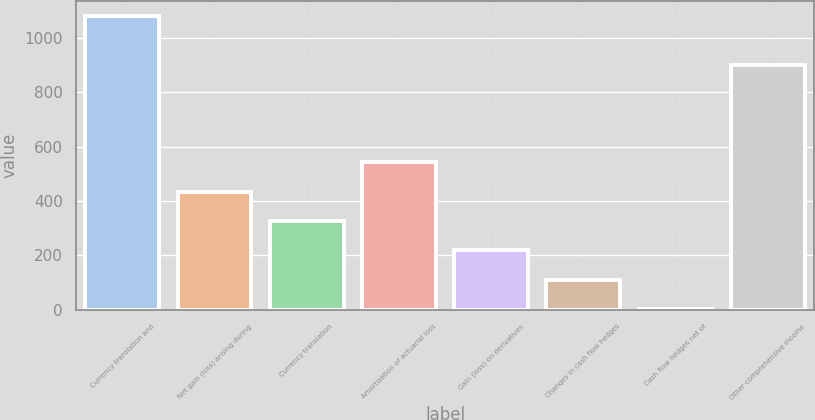Convert chart to OTSL. <chart><loc_0><loc_0><loc_500><loc_500><bar_chart><fcel>Currency translation and<fcel>Net gain (loss) arising during<fcel>Currency translation<fcel>Amortization of actuarial loss<fcel>Gain (loss) on derivatives<fcel>Changes in cash flow hedges<fcel>Cash flow hedges net of<fcel>Other comprehensive income<nl><fcel>1080<fcel>434.4<fcel>326.8<fcel>542<fcel>219.2<fcel>111.6<fcel>4<fcel>899<nl></chart> 